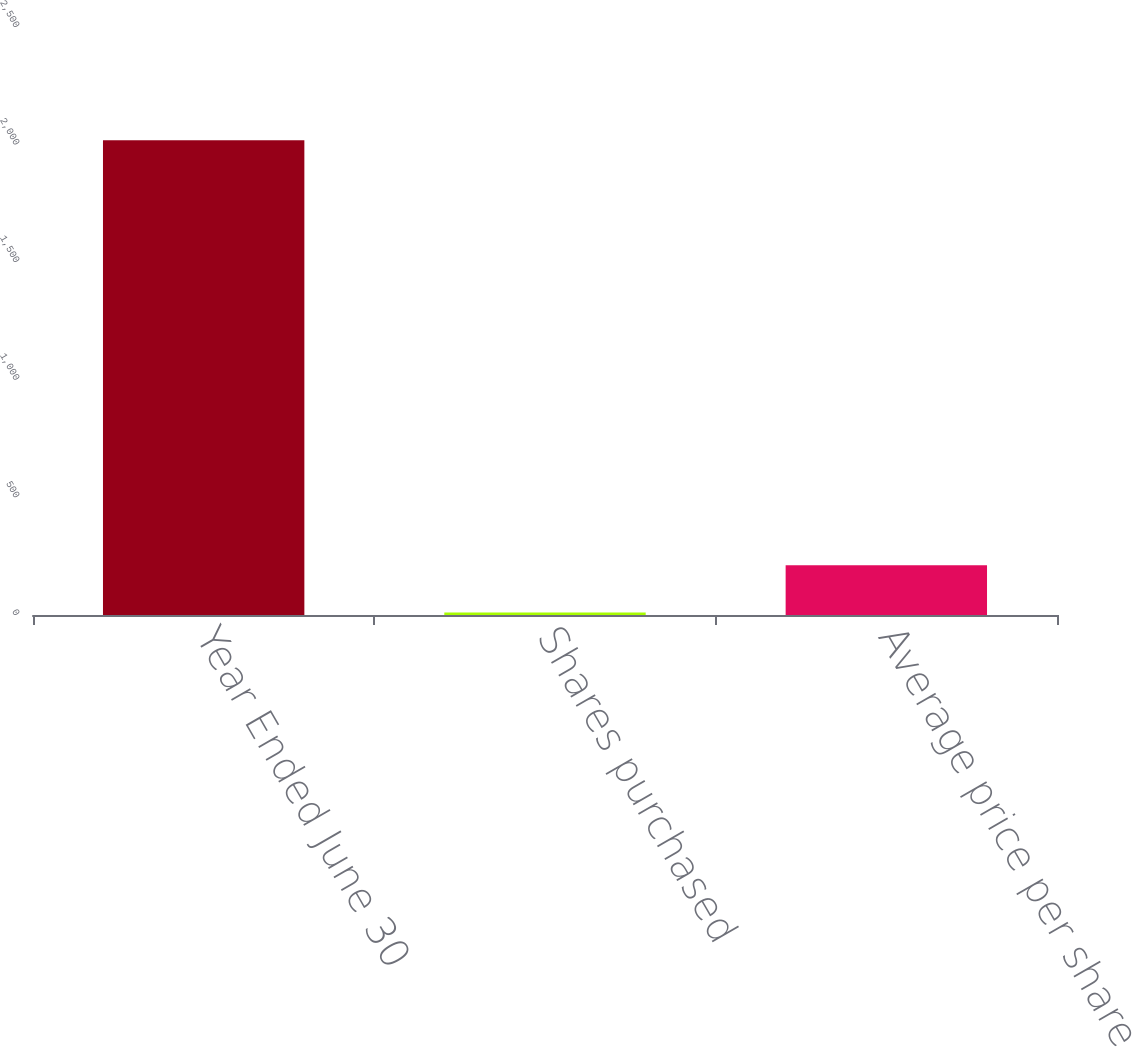Convert chart to OTSL. <chart><loc_0><loc_0><loc_500><loc_500><bar_chart><fcel>Year Ended June 30<fcel>Shares purchased<fcel>Average price per share<nl><fcel>2019<fcel>11<fcel>211.8<nl></chart> 